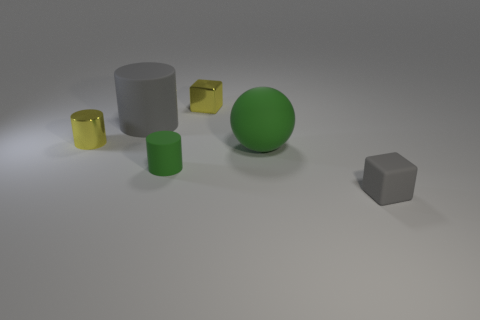How many other objects are the same shape as the small gray matte thing?
Offer a terse response. 1. There is a rubber thing that is in front of the green rubber ball and to the right of the tiny yellow metallic cube; what shape is it?
Ensure brevity in your answer.  Cube. The metal object in front of the small cube behind the gray thing that is in front of the tiny green rubber object is what color?
Provide a succinct answer. Yellow. Is the number of tiny shiny things that are to the right of the small gray matte block greater than the number of objects that are in front of the tiny green rubber cylinder?
Offer a very short reply. No. How many other objects are the same size as the yellow cube?
Your answer should be compact. 3. There is a cylinder that is the same color as the tiny matte cube; what size is it?
Offer a terse response. Large. There is a gray thing behind the gray rubber object that is in front of the small yellow cylinder; what is its material?
Give a very brief answer. Rubber. There is a big green rubber object; are there any blocks to the left of it?
Your answer should be very brief. Yes. Are there more cylinders behind the large rubber ball than big matte cylinders?
Offer a very short reply. Yes. Is there a cube that has the same color as the tiny shiny cylinder?
Offer a terse response. Yes. 